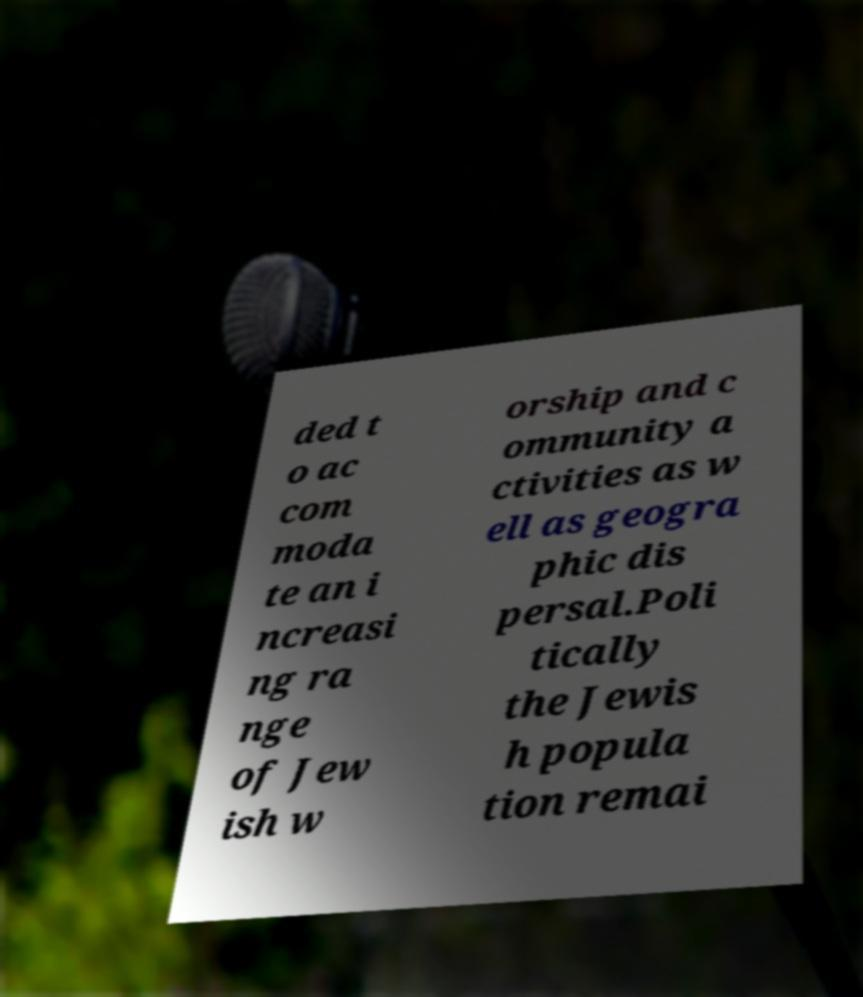What messages or text are displayed in this image? I need them in a readable, typed format. ded t o ac com moda te an i ncreasi ng ra nge of Jew ish w orship and c ommunity a ctivities as w ell as geogra phic dis persal.Poli tically the Jewis h popula tion remai 